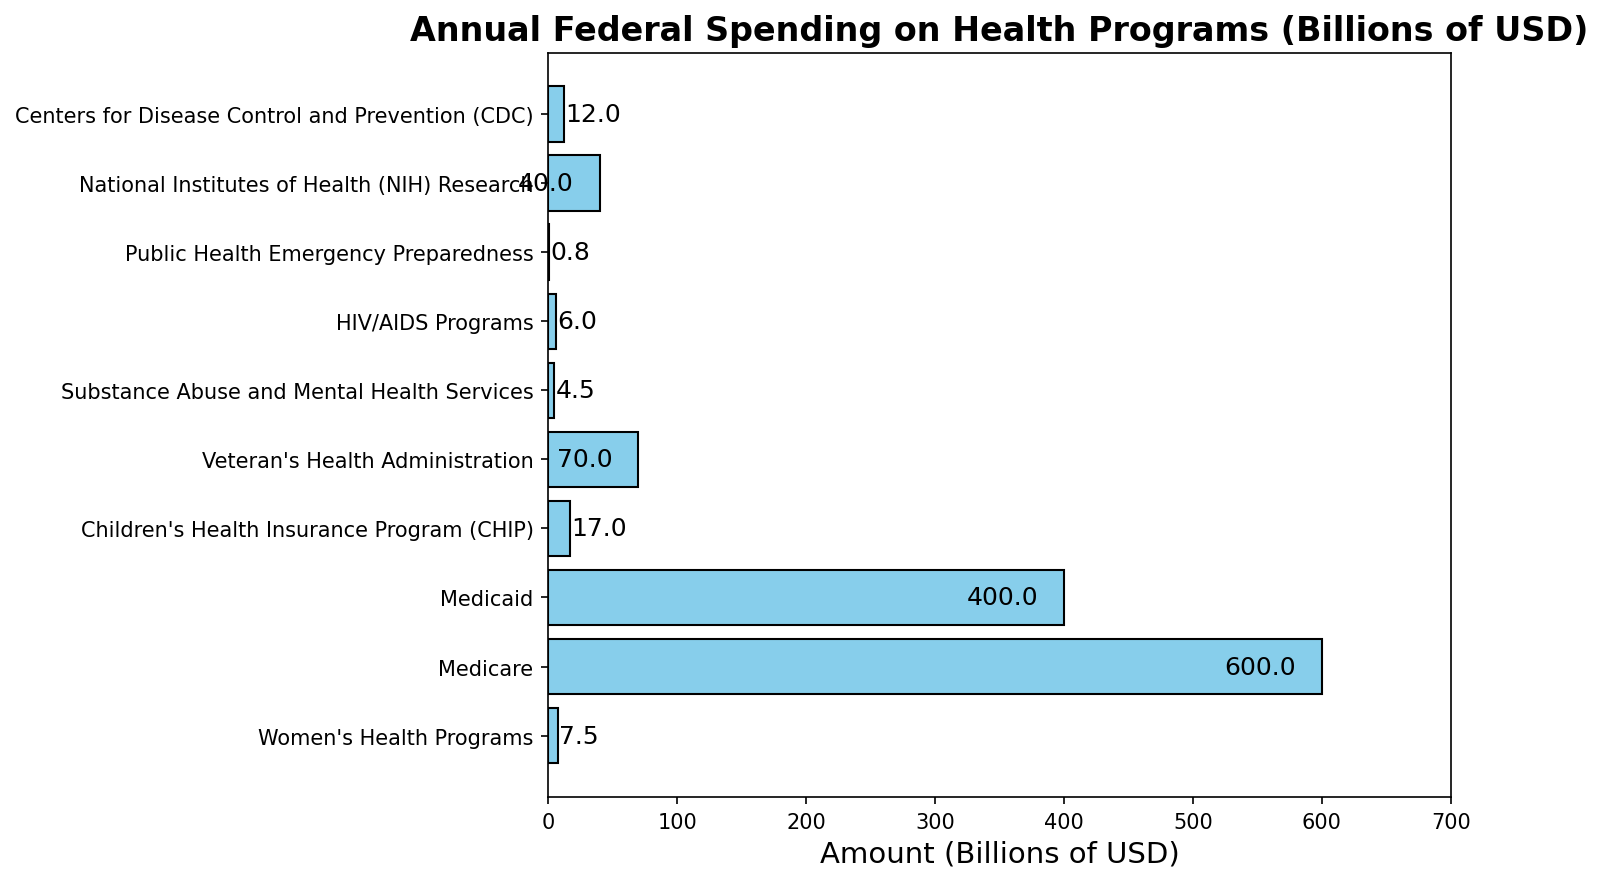What's the total combined spending on Medicare, Medicaid, and NIH Research? To find the total combined spending, sum the amounts for Medicare, Medicaid, and NIH Research: 600 + 400 + 40 = 1040 billion USD
Answer: 1040 billion USD How does the spending on Women's Health Programs compare to Veteran's Health Administration? Check the values for Women's Health Programs (7.5 billion USD) and Veteran's Health Administration (70 billion USD) and compare them. 70 is significantly larger than 7.5, meaning more is spent on Veteran's Health Administration.
Answer: Veteran's Health Administration spending is higher Is the spending on Substance Abuse and Mental Health Services more or less than the spending on HIV/AIDS Programs? Compare the values for Substance Abuse and Mental Health Services (4.5 billion USD) and HIV/AIDS Programs (6 billion USD). Since 4.5 is less than 6, the spending on Substance Abuse and Mental Health Services is less.
Answer: Less What's the difference between the highest and lowest spending categories? Identify the highest spending category (Medicare at 600 billion USD) and the lowest spending category (Public Health Emergency Preparedness at 0.75 billion USD). The difference is 600 - 0.75 = 599.25 billion USD.
Answer: 599.25 billion USD What are the total federal spending amounts on women's health, children's health, and public health preparedness programs combined? Sum the amounts for Women's Health Programs (7.5 billion USD), Children's Health Insurance Program (CHIP) (17 billion USD), and Public Health Emergency Preparedness (0.75 billion USD). The total is 7.5 + 17 + 0.75 = 25.25 billion USD.
Answer: 25.25 billion USD Which category has the second lowest spending? Arrange the spending amounts and identify the second lowest. The lowest is Public Health Emergency Preparedness at 0.75 billion USD; the second lowest is Substance Abuse and Mental Health Services at 4.5 billion USD.
Answer: Substance Abuse and Mental Health Services Is the spending on Medicare more than three times the spending on Medicaid? Check the values: Spending on Medicare is 600 billion USD and on Medicaid is 400 billion USD. Compare if 600 is more than 3 * 400. 600 is not more than 1,200.
Answer: No How do NIH Research and CDC spending compare in terms of federal investment? NIH Research is allocated 40 billion USD and CDC is allocated 12 billion USD. NIH Research receives more investment.
Answer: NIH Research receives more Is the combined spending on Medicare and Medicaid greater than the combined spending on all other health programs listed? Calculate the combined spending on Medicare and Medicaid (600 + 400 = 1000 billion USD) and all other programs (7.5 + 17 + 70 + 4.5 + 6 + 0.75 + 40 + 12 = 157.75 billion USD). 1,000 billion USD is greater than 157.75 billion USD.
Answer: Yes 